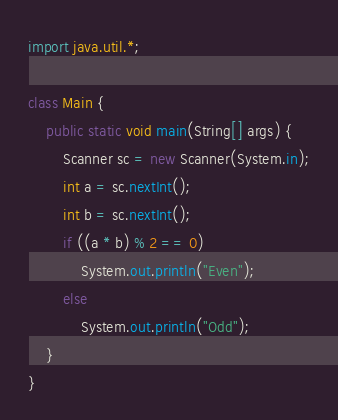Convert code to text. <code><loc_0><loc_0><loc_500><loc_500><_Java_>import java.util.*;

class Main {
    public static void main(String[] args) {
        Scanner sc = new Scanner(System.in);
        int a = sc.nextInt();
        int b = sc.nextInt();
        if ((a * b) % 2 == 0)
            System.out.println("Even");
        else
            System.out.println("Odd");
    }
}</code> 